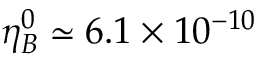<formula> <loc_0><loc_0><loc_500><loc_500>\eta _ { B } ^ { 0 } \simeq 6 . 1 \times 1 0 ^ { - 1 0 }</formula> 